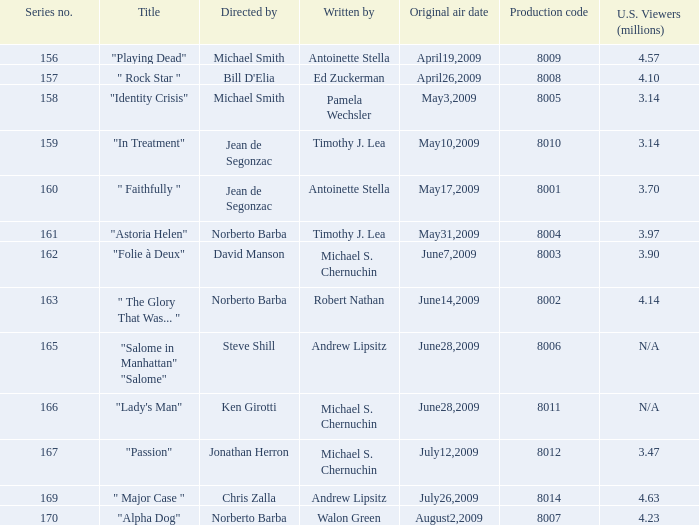How many writers write the episode whose director is Jonathan Herron? 1.0. 